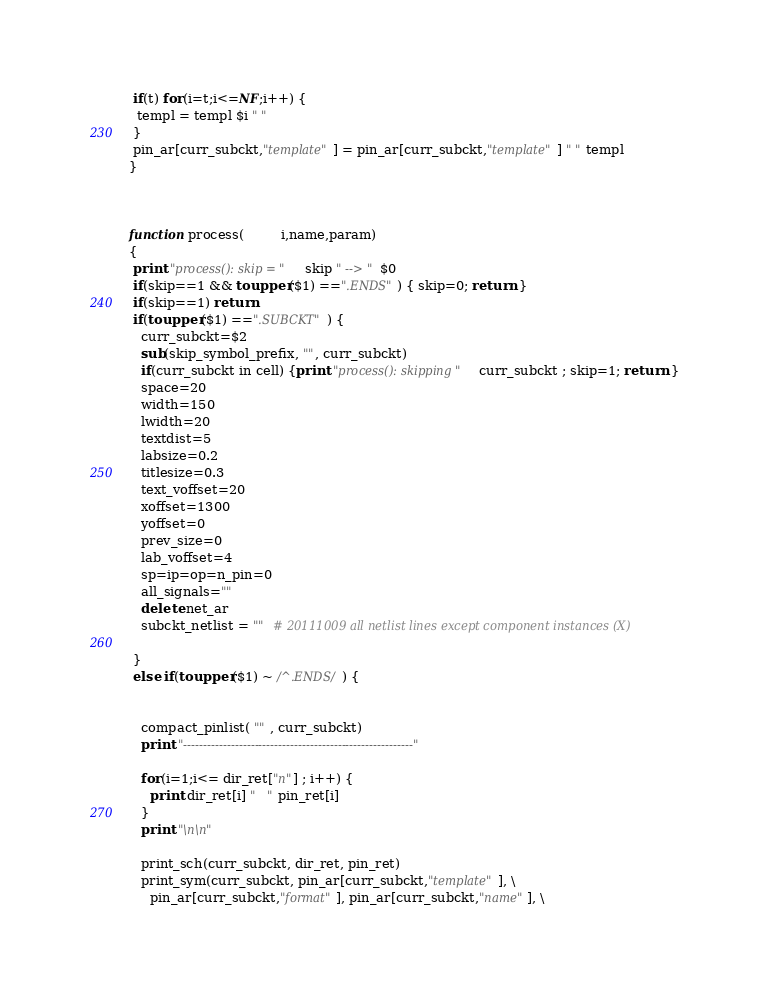<code> <loc_0><loc_0><loc_500><loc_500><_Awk_> if(t) for(i=t;i<=NF;i++) {
  templ = templ $i " " 
 }
 pin_ar[curr_subckt,"template"] = pin_ar[curr_subckt,"template"] " " templ
}


   
function process(         i,name,param)
{
 print "process(): skip = "  skip " --> " $0
 if(skip==1 && toupper($1) ==".ENDS") { skip=0; return }
 if(skip==1) return
 if(toupper($1) ==".SUBCKT") {
   curr_subckt=$2
   sub(skip_symbol_prefix, "", curr_subckt)
   if(curr_subckt in cell) {print "process(): skipping " curr_subckt ; skip=1; return }
   space=20
   width=150
   lwidth=20
   textdist=5
   labsize=0.2
   titlesize=0.3
   text_voffset=20
   xoffset=1300
   yoffset=0
   prev_size=0
   lab_voffset=4
   sp=ip=op=n_pin=0
   all_signals=""
   delete net_ar
   subckt_netlist = ""  # 20111009 all netlist lines except component instances (X) 

 }
 else if(toupper($1) ~ /^.ENDS/) {


   compact_pinlist( "" , curr_subckt)
   print "----------------------------------------------------------"
     
   for(i=1;i<= dir_ret["n"] ; i++) {
     print dir_ret[i] "   " pin_ret[i]
   }   
   print "\n\n"
         
   print_sch(curr_subckt, dir_ret, pin_ret)
   print_sym(curr_subckt, pin_ar[curr_subckt,"template"], \
     pin_ar[curr_subckt,"format"], pin_ar[curr_subckt,"name"], \</code> 